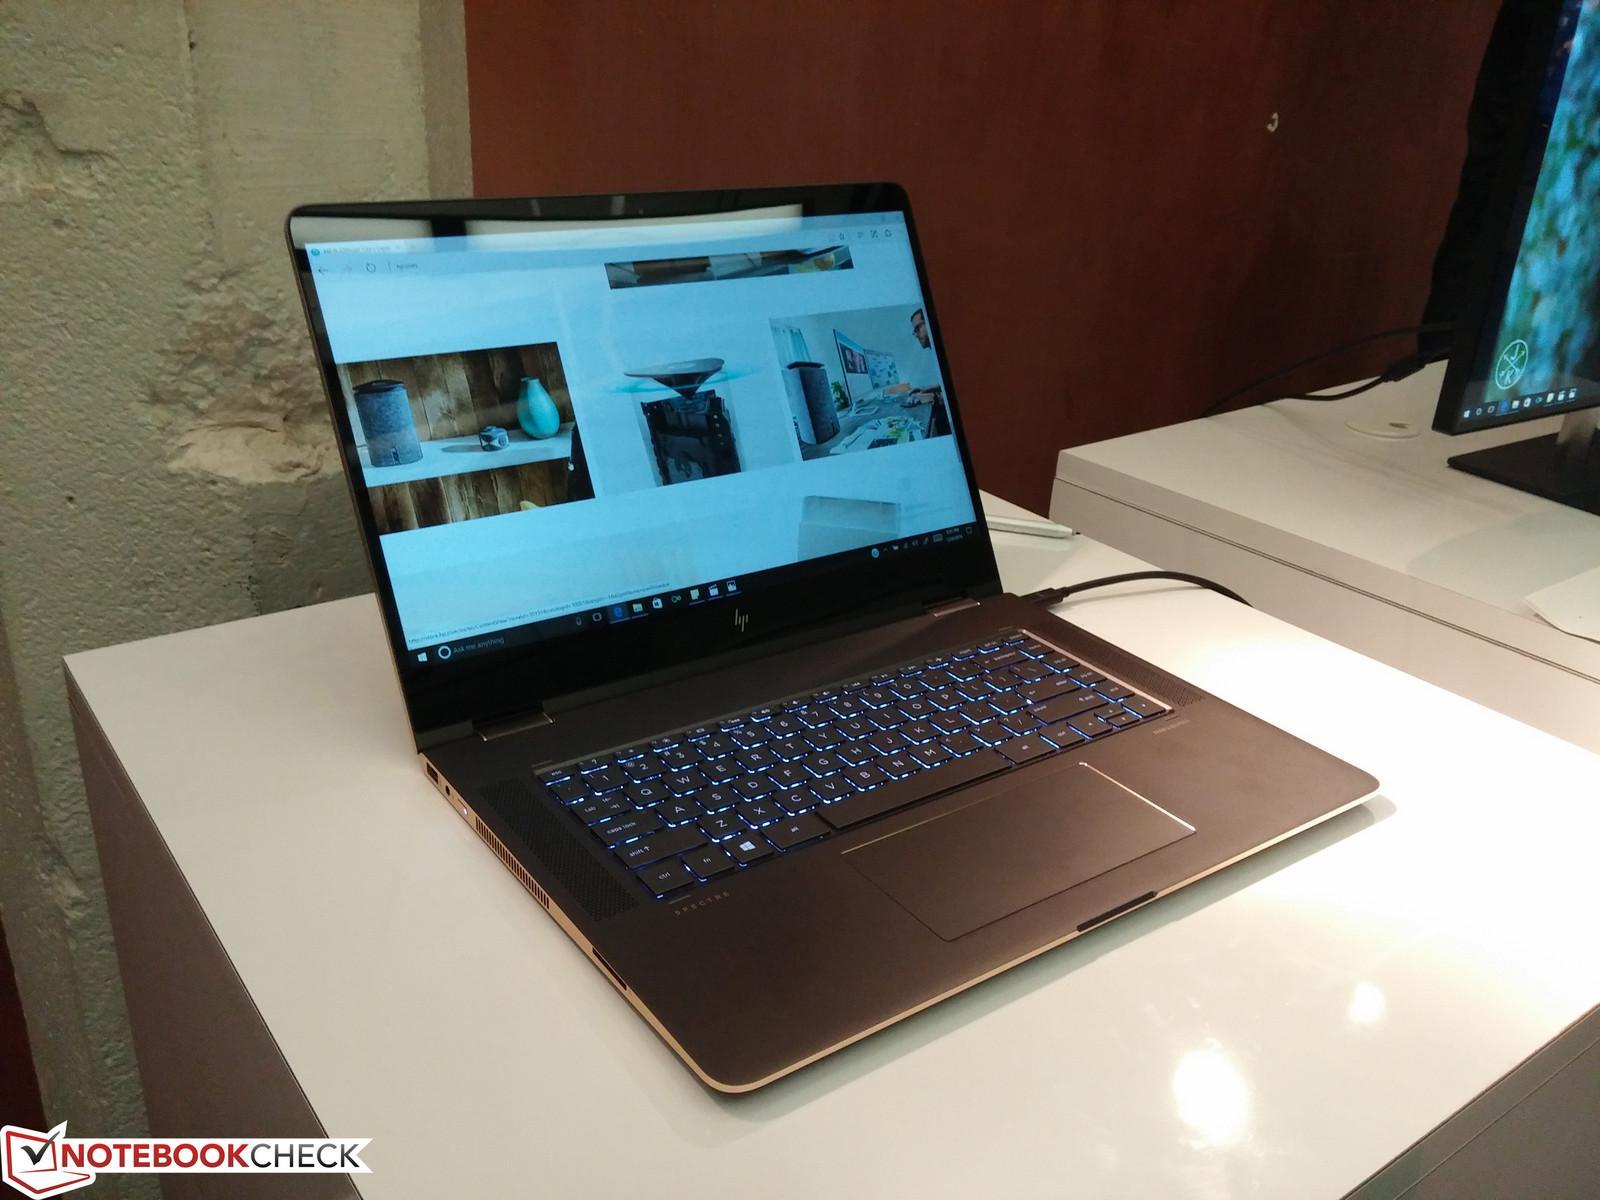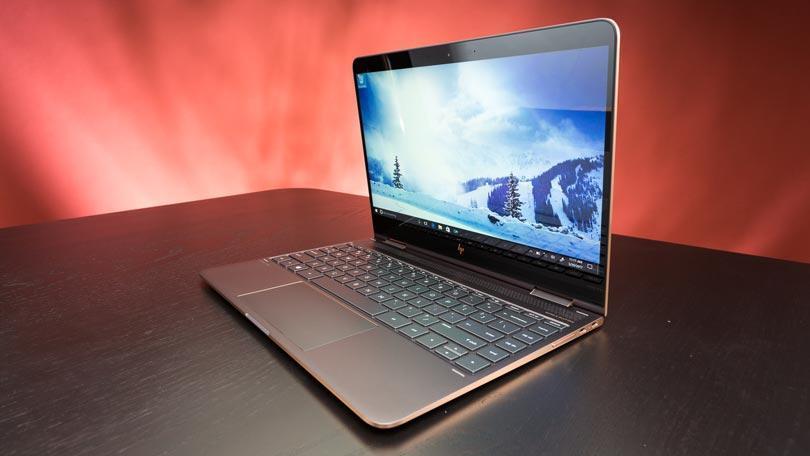The first image is the image on the left, the second image is the image on the right. For the images shown, is this caption "At least one image shows a straight-on side view of a laptop that is opened at less than a 45-degree angle." true? Answer yes or no. No. The first image is the image on the left, the second image is the image on the right. Analyze the images presented: Is the assertion "Two laptop computers are only partially opened, not far enough for a person to use, but far enough to see each has a full keyboard, and below it, a touch pad." valid? Answer yes or no. No. 